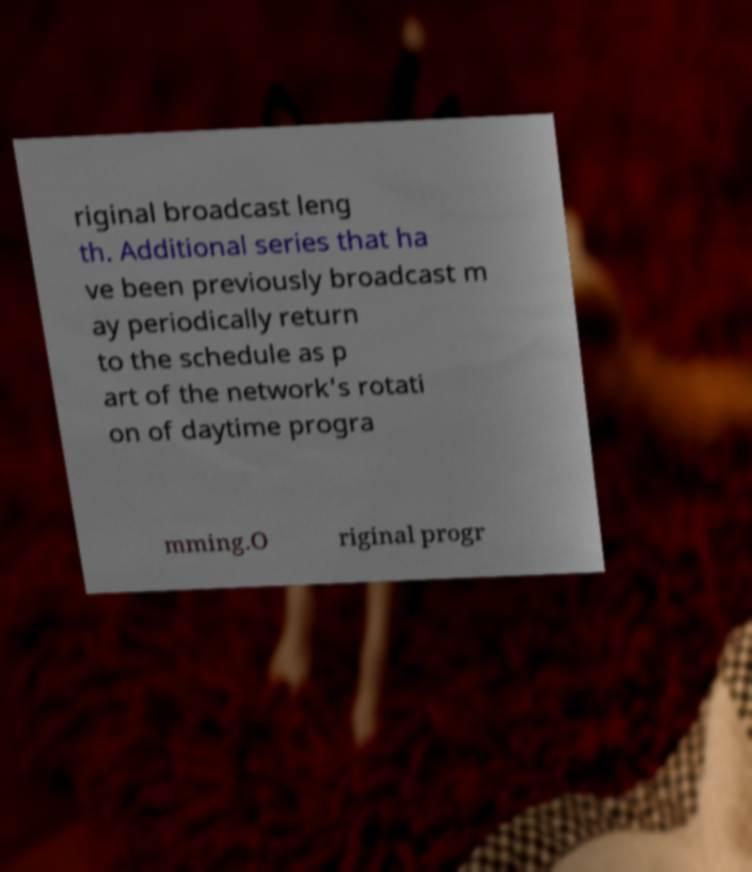What messages or text are displayed in this image? I need them in a readable, typed format. riginal broadcast leng th. Additional series that ha ve been previously broadcast m ay periodically return to the schedule as p art of the network's rotati on of daytime progra mming.O riginal progr 